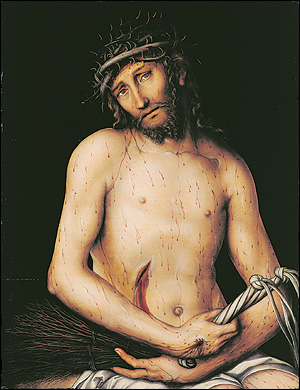Can you describe the emotional impact this image might have on viewers? The image can evoke a deep sense of empathy and sadness, primarily due to the visible signs of suffering on Christ's body and his solemn facial expression. The use of dark colors enhances the overall mournful mood, inviting viewers to reflect on themes of sacrifice and redemption. This artistic depiction encourages a profound emotional connection, often prompting contemplation on personal and spiritual levels. 